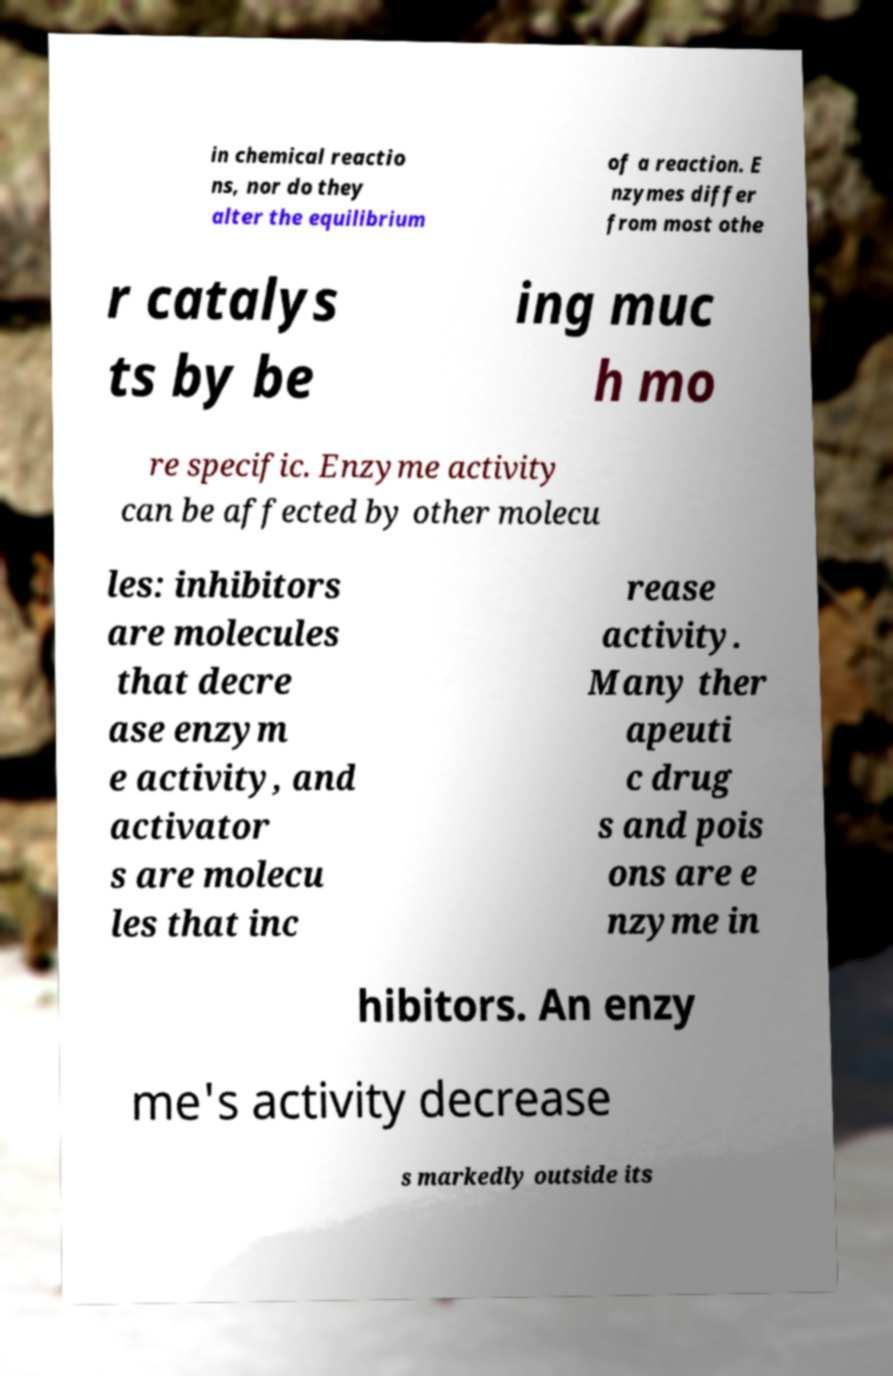Please identify and transcribe the text found in this image. in chemical reactio ns, nor do they alter the equilibrium of a reaction. E nzymes differ from most othe r catalys ts by be ing muc h mo re specific. Enzyme activity can be affected by other molecu les: inhibitors are molecules that decre ase enzym e activity, and activator s are molecu les that inc rease activity. Many ther apeuti c drug s and pois ons are e nzyme in hibitors. An enzy me's activity decrease s markedly outside its 